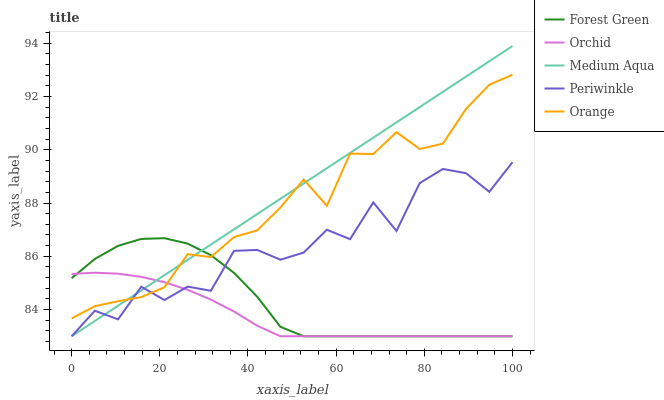Does Orchid have the minimum area under the curve?
Answer yes or no. Yes. Does Medium Aqua have the maximum area under the curve?
Answer yes or no. Yes. Does Periwinkle have the minimum area under the curve?
Answer yes or no. No. Does Periwinkle have the maximum area under the curve?
Answer yes or no. No. Is Medium Aqua the smoothest?
Answer yes or no. Yes. Is Periwinkle the roughest?
Answer yes or no. Yes. Is Forest Green the smoothest?
Answer yes or no. No. Is Forest Green the roughest?
Answer yes or no. No. Does Periwinkle have the lowest value?
Answer yes or no. Yes. Does Medium Aqua have the highest value?
Answer yes or no. Yes. Does Periwinkle have the highest value?
Answer yes or no. No. Does Medium Aqua intersect Orange?
Answer yes or no. Yes. Is Medium Aqua less than Orange?
Answer yes or no. No. Is Medium Aqua greater than Orange?
Answer yes or no. No. 